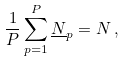Convert formula to latex. <formula><loc_0><loc_0><loc_500><loc_500>\frac { 1 } { P } \sum _ { p = 1 } ^ { P } \underline { N } _ { p } = N \, ,</formula> 